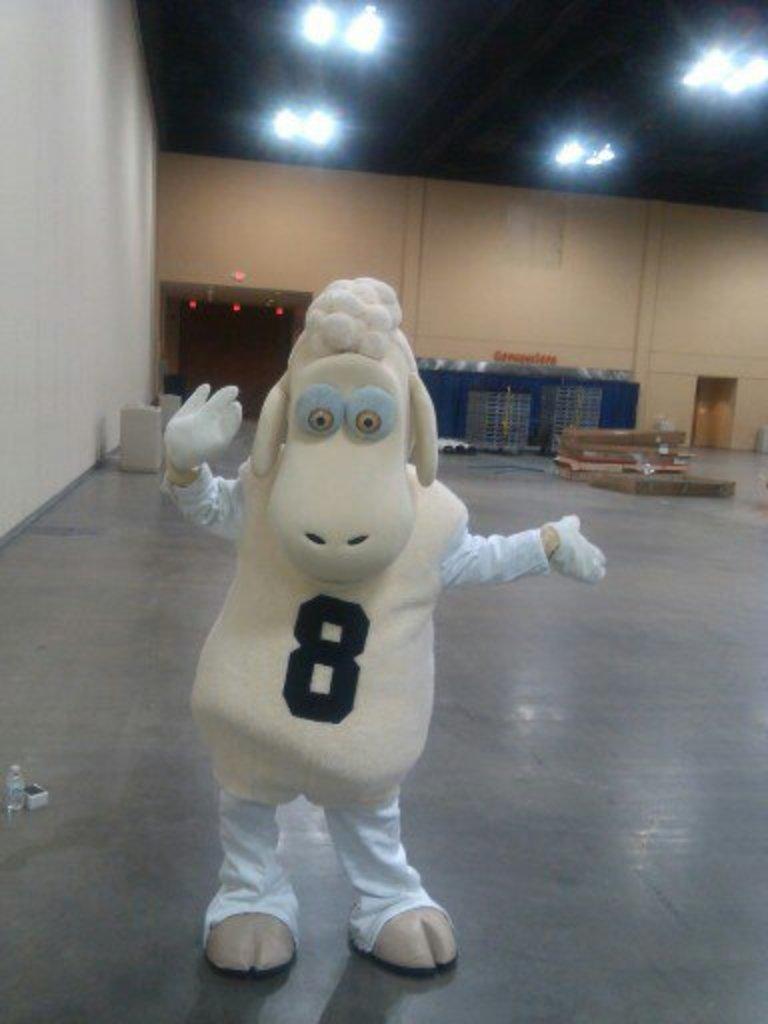Can you describe this image briefly? There is one person standing on the floor and wearing an animal costume in the middle of this image. There is one blue color rectangular box is on the right side to this person. There is a wall in the background. There are some lights arranged at the top of this image. 